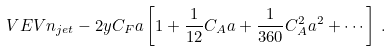Convert formula to latex. <formula><loc_0><loc_0><loc_500><loc_500>\ V E V { n _ { j e t } } - 2 y C _ { F } a \left [ 1 + \frac { 1 } { 1 2 } C _ { A } a + \frac { 1 } { 3 6 0 } C _ { A } ^ { 2 } a ^ { 2 } + \cdots \right ] \, .</formula> 